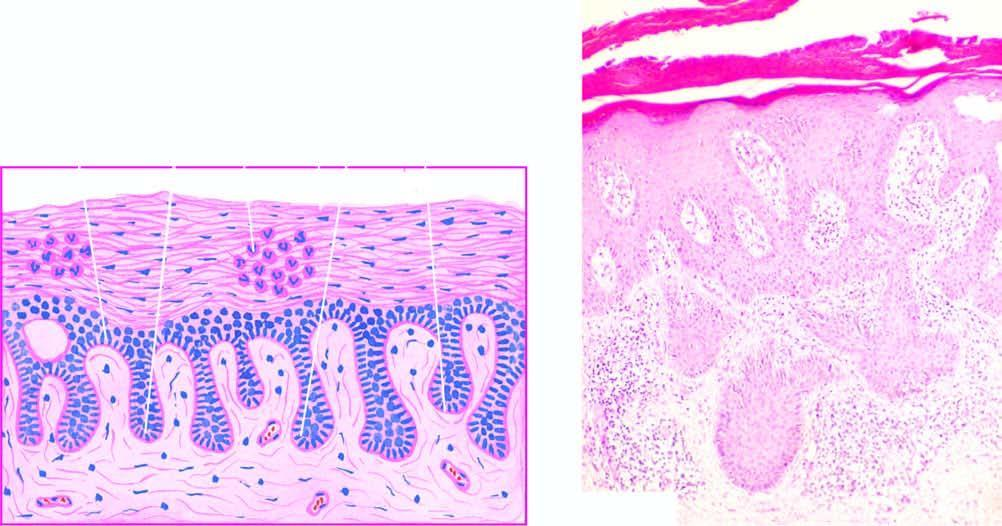s polarising microscopy in photomicrograph on right regular elongation of the rete ridges with thickening of their lower portion?
Answer the question using a single word or phrase. No 